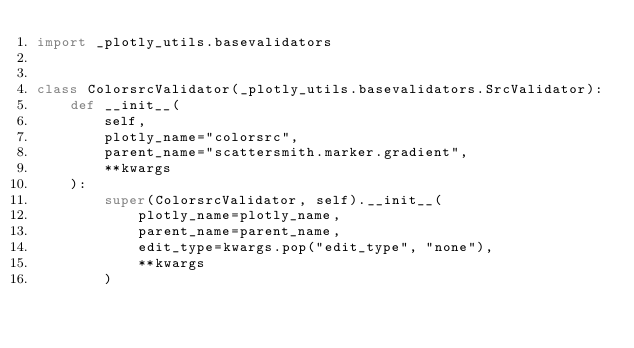Convert code to text. <code><loc_0><loc_0><loc_500><loc_500><_Python_>import _plotly_utils.basevalidators


class ColorsrcValidator(_plotly_utils.basevalidators.SrcValidator):
    def __init__(
        self,
        plotly_name="colorsrc",
        parent_name="scattersmith.marker.gradient",
        **kwargs
    ):
        super(ColorsrcValidator, self).__init__(
            plotly_name=plotly_name,
            parent_name=parent_name,
            edit_type=kwargs.pop("edit_type", "none"),
            **kwargs
        )
</code> 